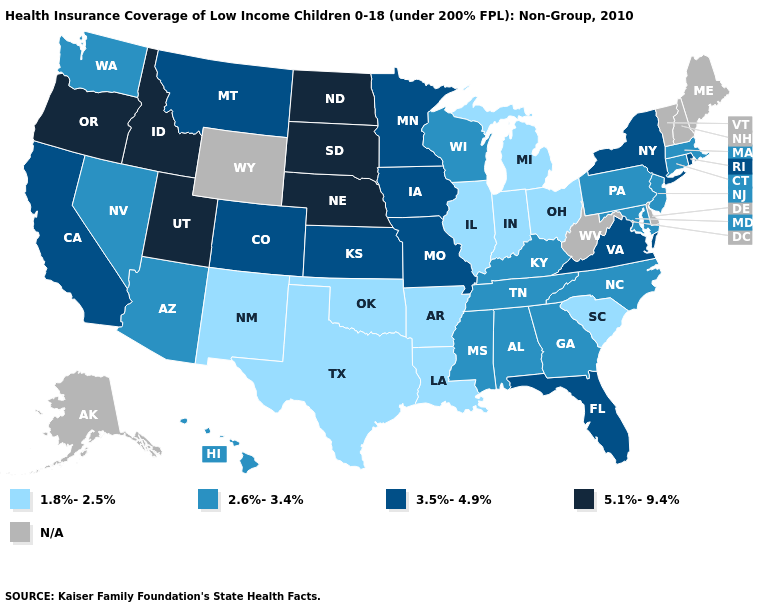What is the value of Alaska?
Answer briefly. N/A. Does Nebraska have the highest value in the USA?
Answer briefly. Yes. What is the highest value in the MidWest ?
Short answer required. 5.1%-9.4%. Name the states that have a value in the range 1.8%-2.5%?
Give a very brief answer. Arkansas, Illinois, Indiana, Louisiana, Michigan, New Mexico, Ohio, Oklahoma, South Carolina, Texas. Name the states that have a value in the range N/A?
Be succinct. Alaska, Delaware, Maine, New Hampshire, Vermont, West Virginia, Wyoming. Among the states that border Utah , does Nevada have the lowest value?
Short answer required. No. Name the states that have a value in the range N/A?
Answer briefly. Alaska, Delaware, Maine, New Hampshire, Vermont, West Virginia, Wyoming. What is the lowest value in the Northeast?
Be succinct. 2.6%-3.4%. Does the first symbol in the legend represent the smallest category?
Concise answer only. Yes. What is the value of Vermont?
Write a very short answer. N/A. Name the states that have a value in the range 2.6%-3.4%?
Quick response, please. Alabama, Arizona, Connecticut, Georgia, Hawaii, Kentucky, Maryland, Massachusetts, Mississippi, Nevada, New Jersey, North Carolina, Pennsylvania, Tennessee, Washington, Wisconsin. Which states have the lowest value in the USA?
Keep it brief. Arkansas, Illinois, Indiana, Louisiana, Michigan, New Mexico, Ohio, Oklahoma, South Carolina, Texas. Name the states that have a value in the range 2.6%-3.4%?
Be succinct. Alabama, Arizona, Connecticut, Georgia, Hawaii, Kentucky, Maryland, Massachusetts, Mississippi, Nevada, New Jersey, North Carolina, Pennsylvania, Tennessee, Washington, Wisconsin. What is the value of Wyoming?
Be succinct. N/A. 